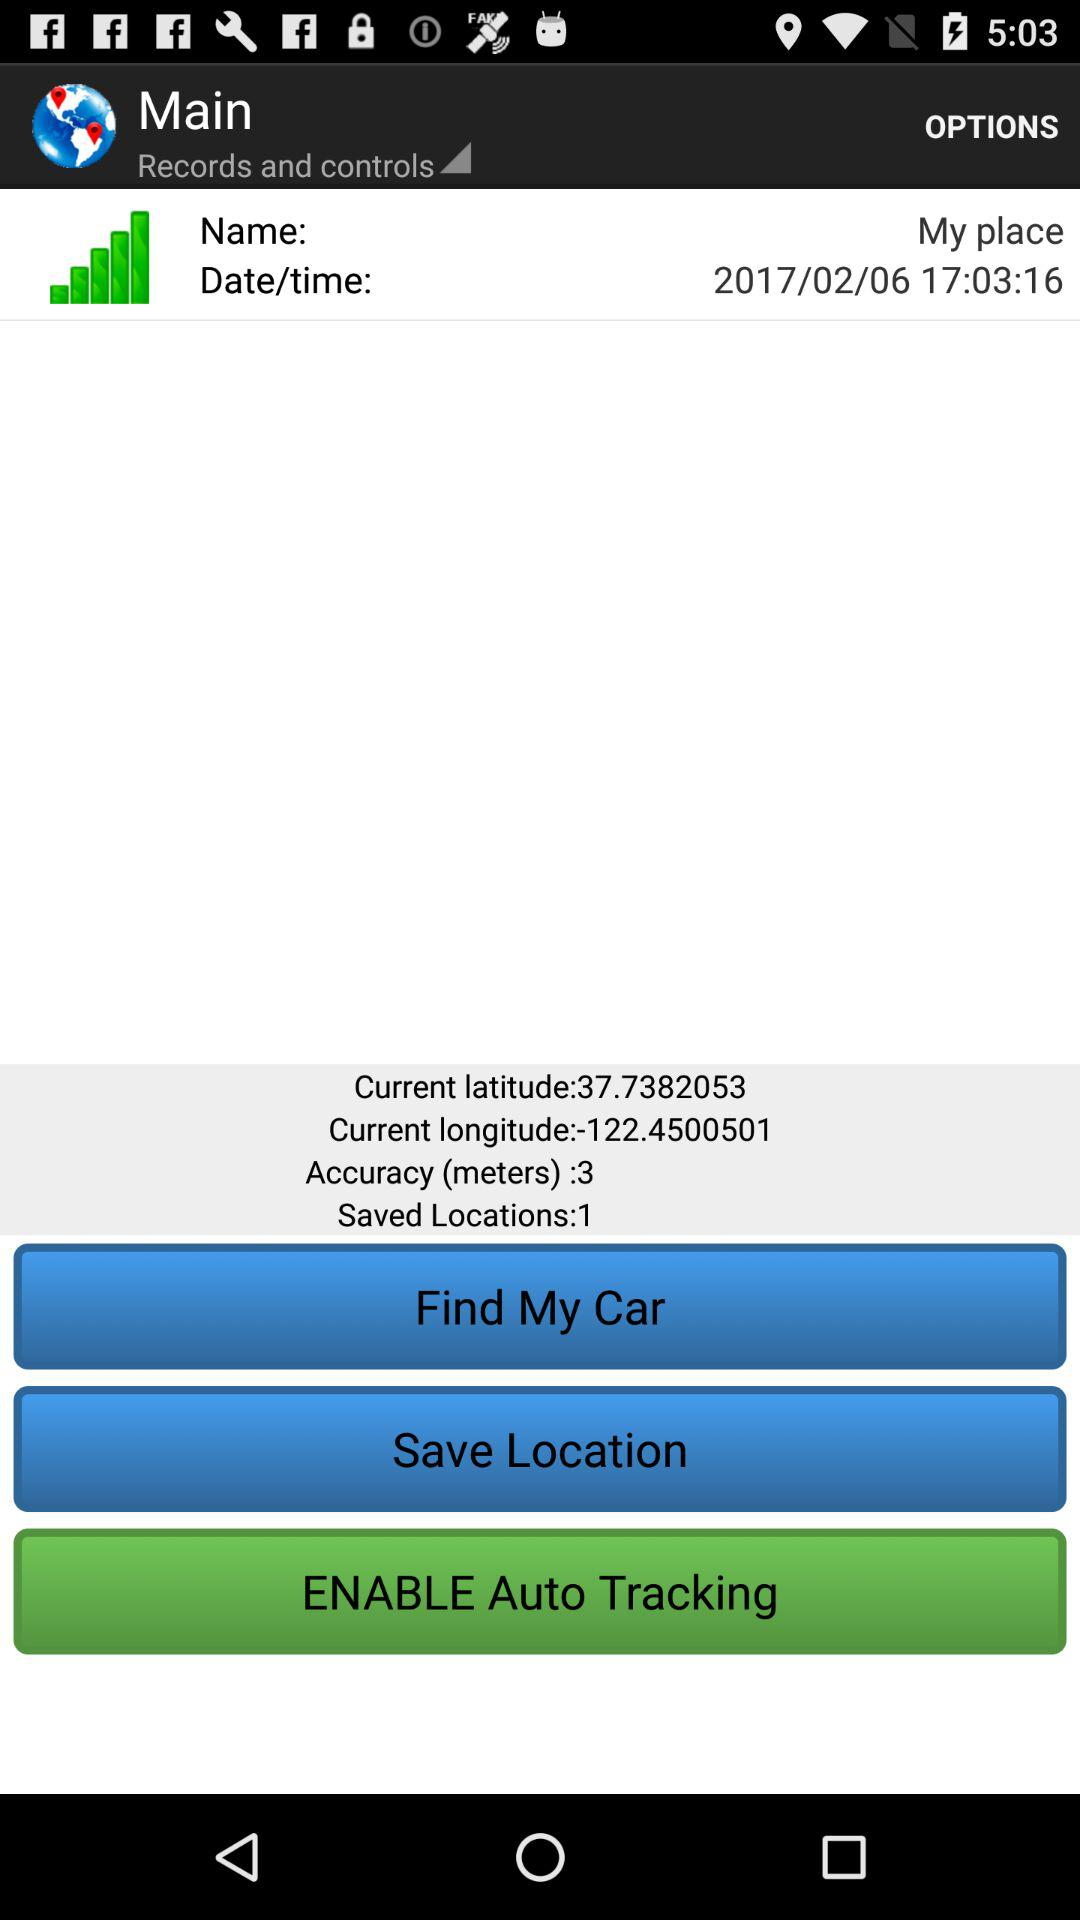What is the current longitude? The current longitude is -122.4500501. 